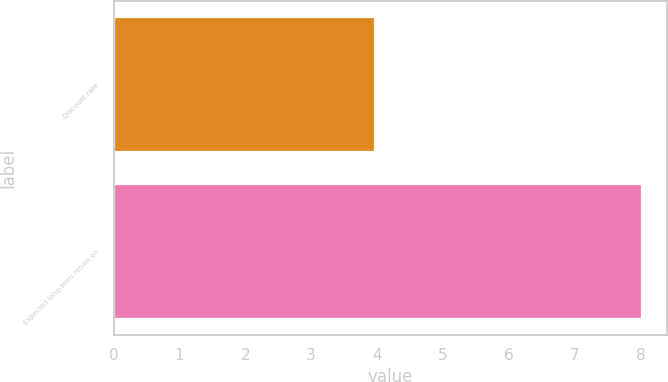Convert chart to OTSL. <chart><loc_0><loc_0><loc_500><loc_500><bar_chart><fcel>Discount rate<fcel>Expected long-term return on<nl><fcel>3.95<fcel>8<nl></chart> 